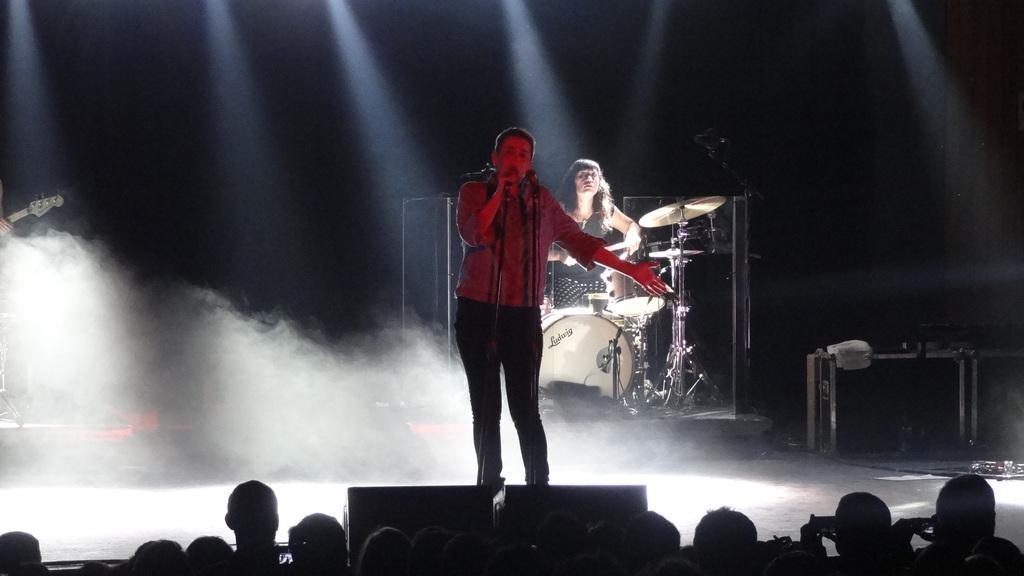Could you give a brief overview of what you see in this image? This picture seems to be clicked inside. In the foreground we can see the group of persons. In the center there is a person standing and holding a microphone and seems to be singing. In the background we can see the lights and a person seems to be playing some musical instruments and there are some musical instruments placed on the ground. On the left corner we can see the hand of a person holding a guitar. 